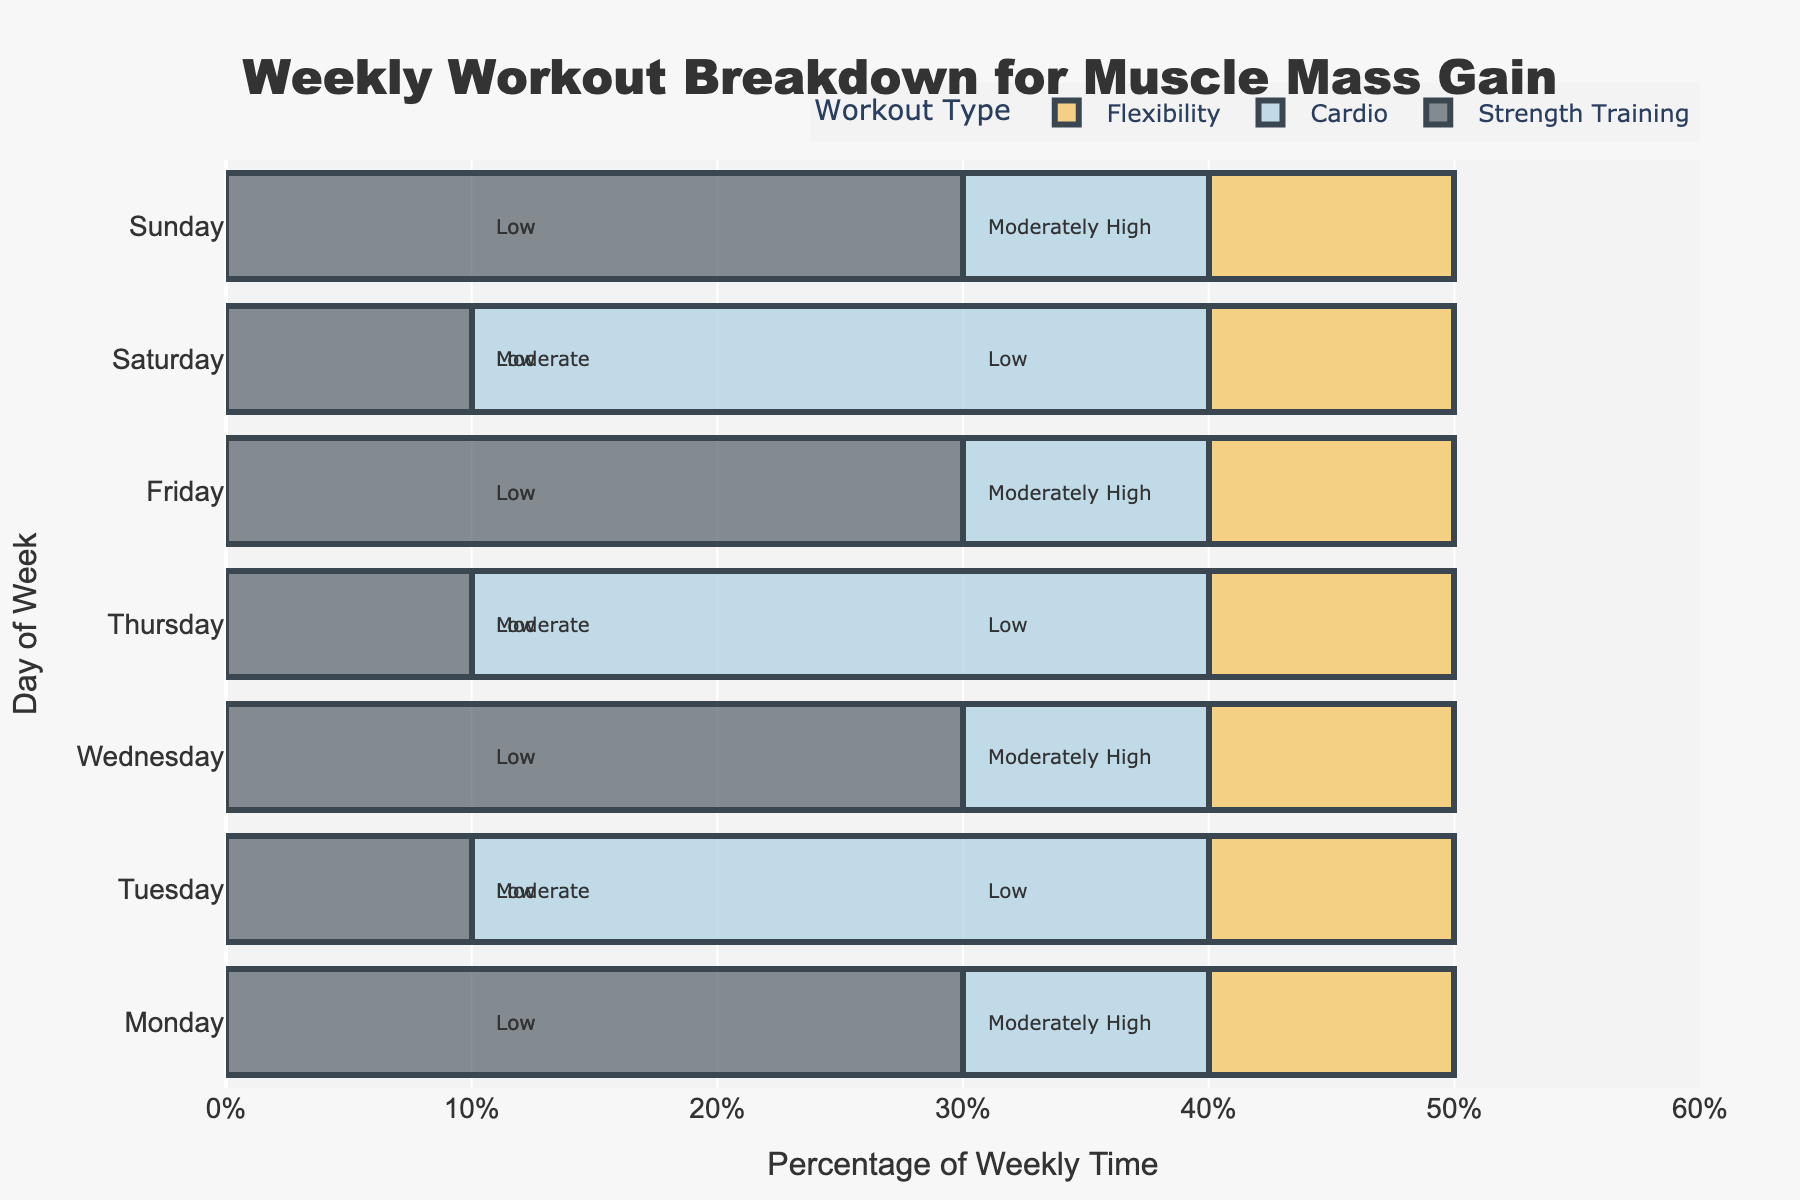What percentage of weekly time is spent on Strength Training on Monday compared to Tuesday? Strength Training on Monday is 30%. Strength Training on Tuesday is 10%. Comparing the two: Monday (30%) is 20% more than Tuesday (10%).
Answer: 20% Which workout type has the highest impact on muscle recovery time across all days? Strength Training has the highest impact on muscle recovery time, which is labeled as "Moderately High" on four days (Monday, Wednesday, Friday, and Sunday). Cardio and Flexibility are labeled as "Low" or "Moderate".
Answer: Strength Training What is the total percentage of weekly time spent on Cardio across all days? Cardio is 10% on Monday, Wednesday, Friday, and Sunday, and 30% on Tuesday, Thursday, and Saturday. Adding these: 10% * 4 + 30% * 3 = 40% + 90% = 130%.
Answer: 130% How does the percentage of weekly time spent on Flexibility compare between Monday and Saturday? Flexibility on Monday is 10%. Flexibility on Saturday is also 10%. Both are the same.
Answer: Same Is there any day where only one workout type is performed? No day has a single type of workout. Each day includes all three types: Strength Training, Cardio, and Flexibility, in varying percentages.
Answer: No Which days have the maximum and minimum total percentage of weekly time spent on Strength Training? Maximum: Monday, Wednesday, Friday, Sunday each have 30%. Minimum: Tuesday, Thursday, Saturday each have 10%.
Answer: Maximum: Monday, Wednesday, Friday, Sunday; Minimum: Tuesday, Thursday, Saturday How does the impact on muscle recovery time differ between Cardio and Flexibility workouts on Tuesday? Both Cardio and Flexibility have a "Low" impact on muscle recovery on Tuesday, meaning their impacts are similar.
Answer: Similar What is the cumulative percentage of weekly time spent on Strength Training from Monday to Wednesday? Summing up Strength Training percentages: Monday (30%) + Wednesday (30%) = 60%.
Answer: 60% Which workout type has the lowest overall percentage of weekly time across all days? Flexibility is consistently at 10% each day, making its weekly total: 10% * 7 = 70%. Both other types (Strength Training and Cardio) are higher.
Answer: Flexibility How does the visual color representation of Cardio differentiate in the plot? Cardio is visually represented in a light blue color, different from the darker gray for Strength Training and yellow for Flexibility.
Answer: Light blue 